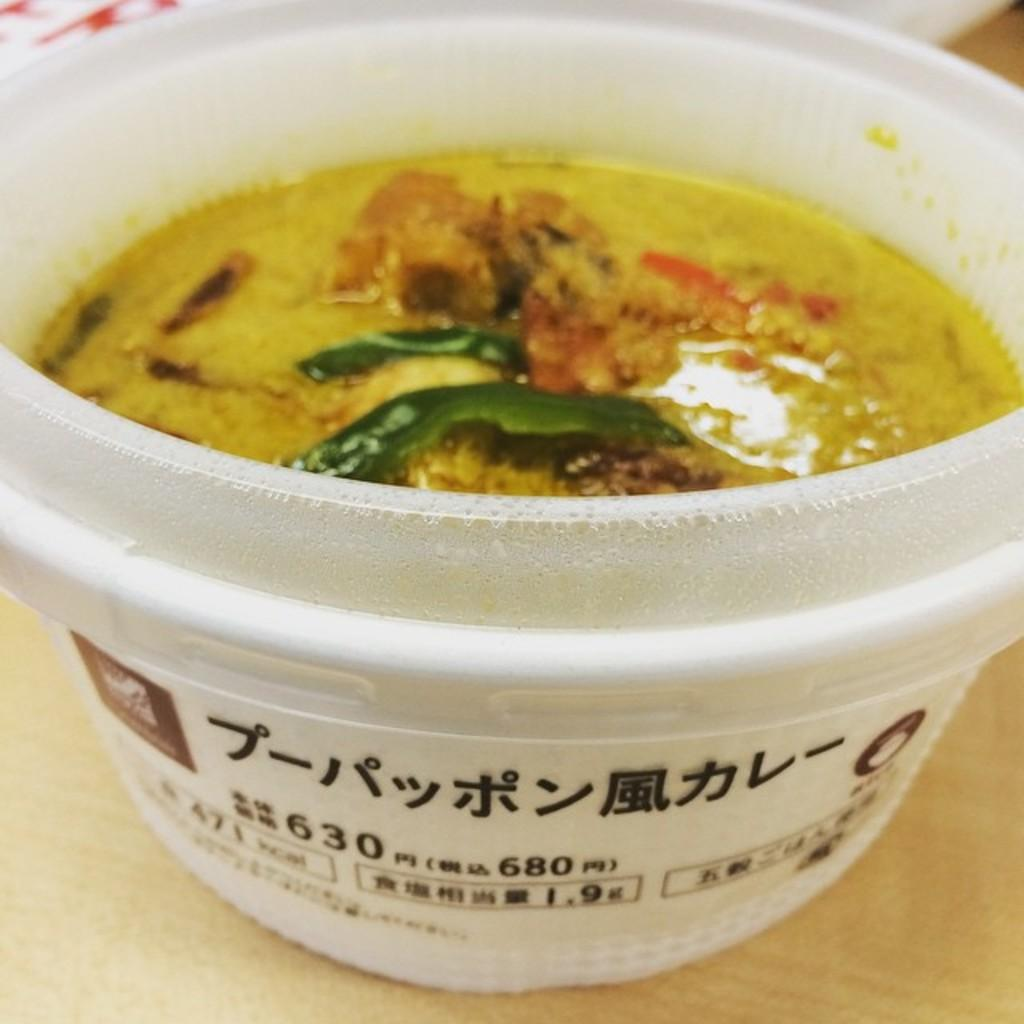What is the color of the surface in the image? The surface in the image is cream-colored. What is placed on the surface? There is a white-colored bowl on the surface. What colors can be seen in the food item inside the bowl? The food item in the bowl has green, yellow, red, and brown colors. How many geese are resting on the beds in the image? There are no geese or beds present in the image. What type of stew is being prepared on the cream-colored surface? There is no stew being prepared in the image; it features a bowl with a food item that has green, yellow, red, and brown colors. 